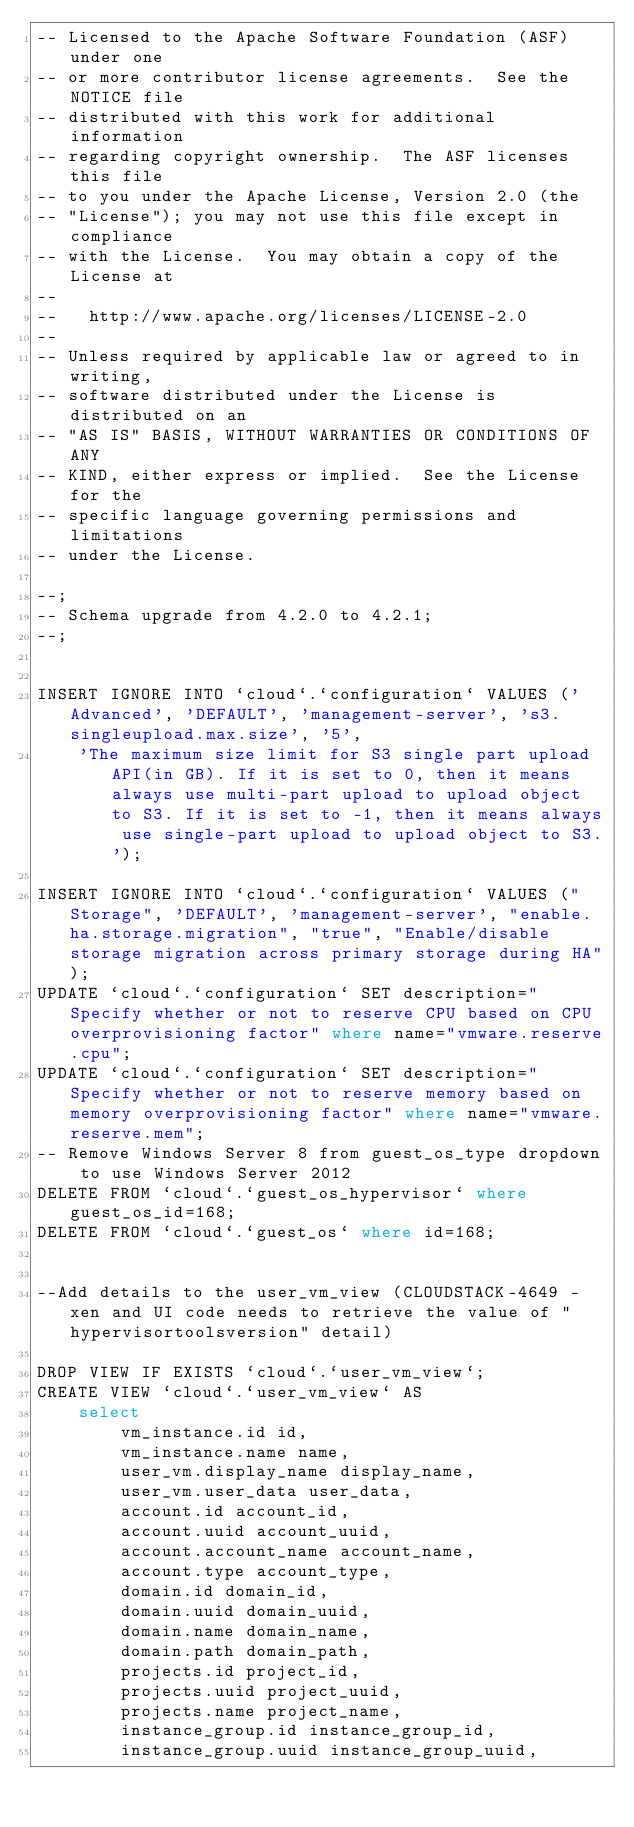<code> <loc_0><loc_0><loc_500><loc_500><_SQL_>-- Licensed to the Apache Software Foundation (ASF) under one
-- or more contributor license agreements.  See the NOTICE file
-- distributed with this work for additional information
-- regarding copyright ownership.  The ASF licenses this file
-- to you under the Apache License, Version 2.0 (the
-- "License"); you may not use this file except in compliance
-- with the License.  You may obtain a copy of the License at
--
--   http://www.apache.org/licenses/LICENSE-2.0
--
-- Unless required by applicable law or agreed to in writing,
-- software distributed under the License is distributed on an
-- "AS IS" BASIS, WITHOUT WARRANTIES OR CONDITIONS OF ANY
-- KIND, either express or implied.  See the License for the
-- specific language governing permissions and limitations
-- under the License.

--;
-- Schema upgrade from 4.2.0 to 4.2.1;
--;


INSERT IGNORE INTO `cloud`.`configuration` VALUES ('Advanced', 'DEFAULT', 'management-server', 's3.singleupload.max.size', '5', 
    'The maximum size limit for S3 single part upload API(in GB). If it is set to 0, then it means always use multi-part upload to upload object to S3. If it is set to -1, then it means always use single-part upload to upload object to S3.');

INSERT IGNORE INTO `cloud`.`configuration` VALUES ("Storage", 'DEFAULT', 'management-server', "enable.ha.storage.migration", "true", "Enable/disable storage migration across primary storage during HA"); 
UPDATE `cloud`.`configuration` SET description="Specify whether or not to reserve CPU based on CPU overprovisioning factor" where name="vmware.reserve.cpu";
UPDATE `cloud`.`configuration` SET description="Specify whether or not to reserve memory based on memory overprovisioning factor" where name="vmware.reserve.mem";
-- Remove Windows Server 8 from guest_os_type dropdown to use Windows Server 2012
DELETE FROM `cloud`.`guest_os_hypervisor` where guest_os_id=168;
DELETE FROM `cloud`.`guest_os` where id=168;


--Add details to the user_vm_view (CLOUDSTACK-4649 - xen and UI code needs to retrieve the value of "hypervisortoolsversion" detail)

DROP VIEW IF EXISTS `cloud`.`user_vm_view`;
CREATE VIEW `cloud`.`user_vm_view` AS
    select
        vm_instance.id id,
        vm_instance.name name,
        user_vm.display_name display_name,
        user_vm.user_data user_data,
        account.id account_id,
        account.uuid account_uuid,
        account.account_name account_name,
        account.type account_type,
        domain.id domain_id,
        domain.uuid domain_uuid,
        domain.name domain_name,
        domain.path domain_path,
        projects.id project_id,
        projects.uuid project_uuid,
        projects.name project_name,
        instance_group.id instance_group_id,
        instance_group.uuid instance_group_uuid,</code> 